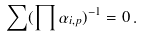<formula> <loc_0><loc_0><loc_500><loc_500>\sum ( \prod \alpha _ { i , p } ) ^ { - 1 } = 0 \, .</formula> 